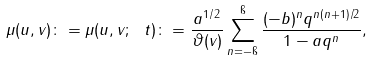<formula> <loc_0><loc_0><loc_500><loc_500>\mu ( u , v ) \colon = \mu ( u , v ; \ t ) \colon = \frac { a ^ { 1 / 2 } } { \vartheta ( v ) } \sum _ { n = - \i } ^ { \i } \frac { ( - b ) ^ { n } q ^ { n ( n + 1 ) / 2 } } { 1 - a q ^ { n } } ,</formula> 